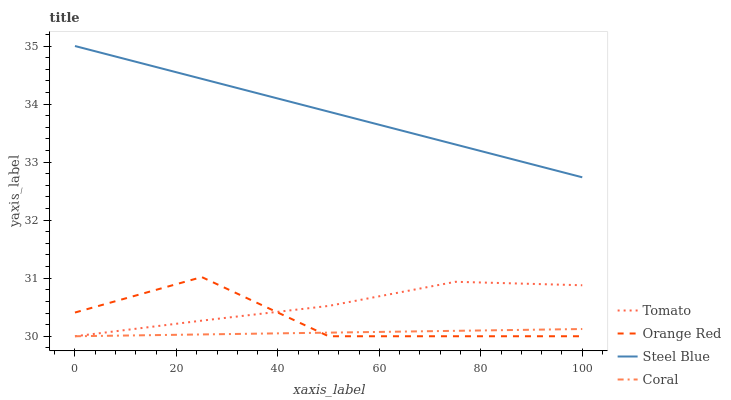Does Coral have the minimum area under the curve?
Answer yes or no. Yes. Does Steel Blue have the maximum area under the curve?
Answer yes or no. Yes. Does Orange Red have the minimum area under the curve?
Answer yes or no. No. Does Orange Red have the maximum area under the curve?
Answer yes or no. No. Is Coral the smoothest?
Answer yes or no. Yes. Is Orange Red the roughest?
Answer yes or no. Yes. Is Orange Red the smoothest?
Answer yes or no. No. Is Coral the roughest?
Answer yes or no. No. Does Tomato have the lowest value?
Answer yes or no. Yes. Does Steel Blue have the lowest value?
Answer yes or no. No. Does Steel Blue have the highest value?
Answer yes or no. Yes. Does Orange Red have the highest value?
Answer yes or no. No. Is Coral less than Steel Blue?
Answer yes or no. Yes. Is Steel Blue greater than Orange Red?
Answer yes or no. Yes. Does Coral intersect Tomato?
Answer yes or no. Yes. Is Coral less than Tomato?
Answer yes or no. No. Is Coral greater than Tomato?
Answer yes or no. No. Does Coral intersect Steel Blue?
Answer yes or no. No. 